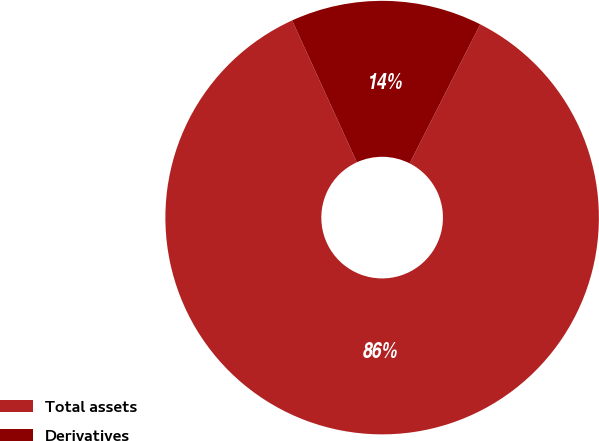Convert chart to OTSL. <chart><loc_0><loc_0><loc_500><loc_500><pie_chart><fcel>Total assets<fcel>Derivatives<nl><fcel>85.71%<fcel>14.29%<nl></chart> 